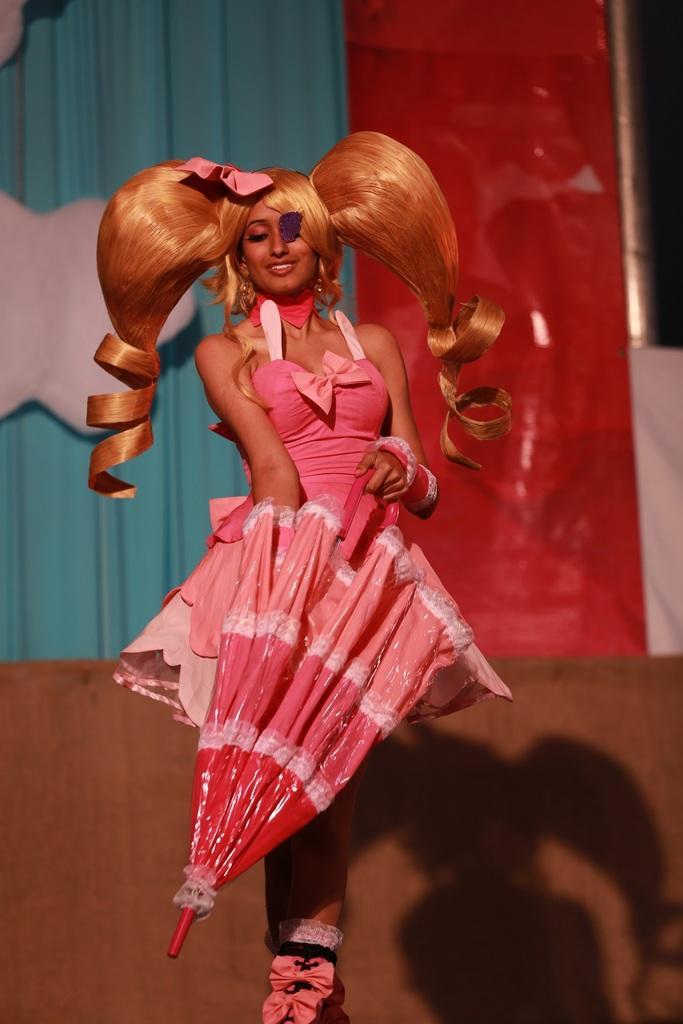Can you describe this image briefly? In front of the image there is a woman with a smile on her face is holding an umbrella, behind the woman there is a curtain on the wall. 